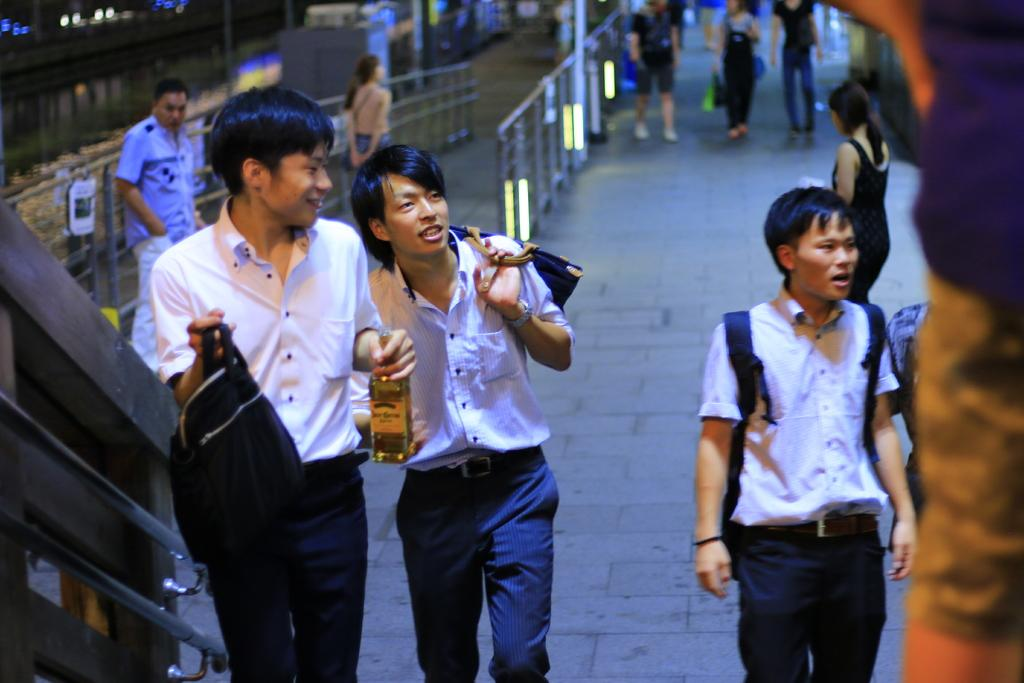What are the people in the image doing? The people in the image are walking. What surface are the people walking on? There is a floor visible in the image. What else can be seen in the image besides the people walking? There is water visible in the image. What type of payment is required to enter the door in the image? There is no door present in the image, so no payment is required. 